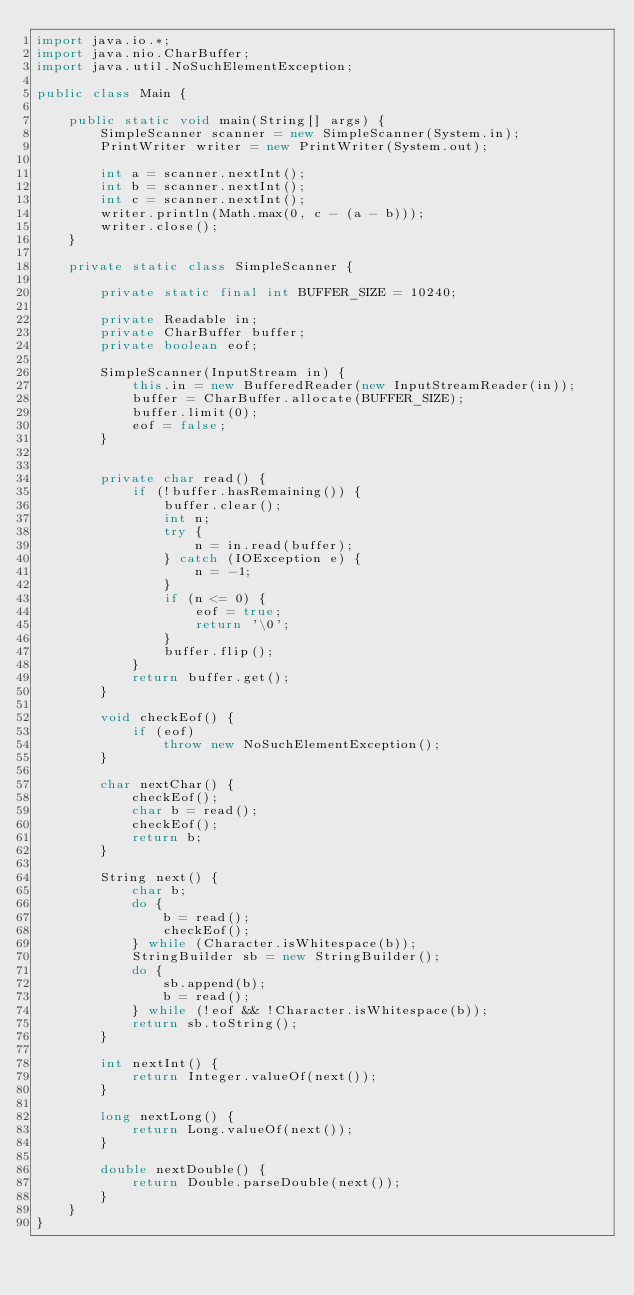Convert code to text. <code><loc_0><loc_0><loc_500><loc_500><_Java_>import java.io.*;
import java.nio.CharBuffer;
import java.util.NoSuchElementException;

public class Main {

    public static void main(String[] args) {
        SimpleScanner scanner = new SimpleScanner(System.in);
        PrintWriter writer = new PrintWriter(System.out);

        int a = scanner.nextInt();
        int b = scanner.nextInt();
        int c = scanner.nextInt();
        writer.println(Math.max(0, c - (a - b)));
        writer.close();
    }

    private static class SimpleScanner {

        private static final int BUFFER_SIZE = 10240;

        private Readable in;
        private CharBuffer buffer;
        private boolean eof;

        SimpleScanner(InputStream in) {
            this.in = new BufferedReader(new InputStreamReader(in));
            buffer = CharBuffer.allocate(BUFFER_SIZE);
            buffer.limit(0);
            eof = false;
        }


        private char read() {
            if (!buffer.hasRemaining()) {
                buffer.clear();
                int n;
                try {
                    n = in.read(buffer);
                } catch (IOException e) {
                    n = -1;
                }
                if (n <= 0) {
                    eof = true;
                    return '\0';
                }
                buffer.flip();
            }
            return buffer.get();
        }

        void checkEof() {
            if (eof)
                throw new NoSuchElementException();
        }

        char nextChar() {
            checkEof();
            char b = read();
            checkEof();
            return b;
        }

        String next() {
            char b;
            do {
                b = read();
                checkEof();
            } while (Character.isWhitespace(b));
            StringBuilder sb = new StringBuilder();
            do {
                sb.append(b);
                b = read();
            } while (!eof && !Character.isWhitespace(b));
            return sb.toString();
        }

        int nextInt() {
            return Integer.valueOf(next());
        }

        long nextLong() {
            return Long.valueOf(next());
        }

        double nextDouble() {
            return Double.parseDouble(next());
        }
    }
}</code> 